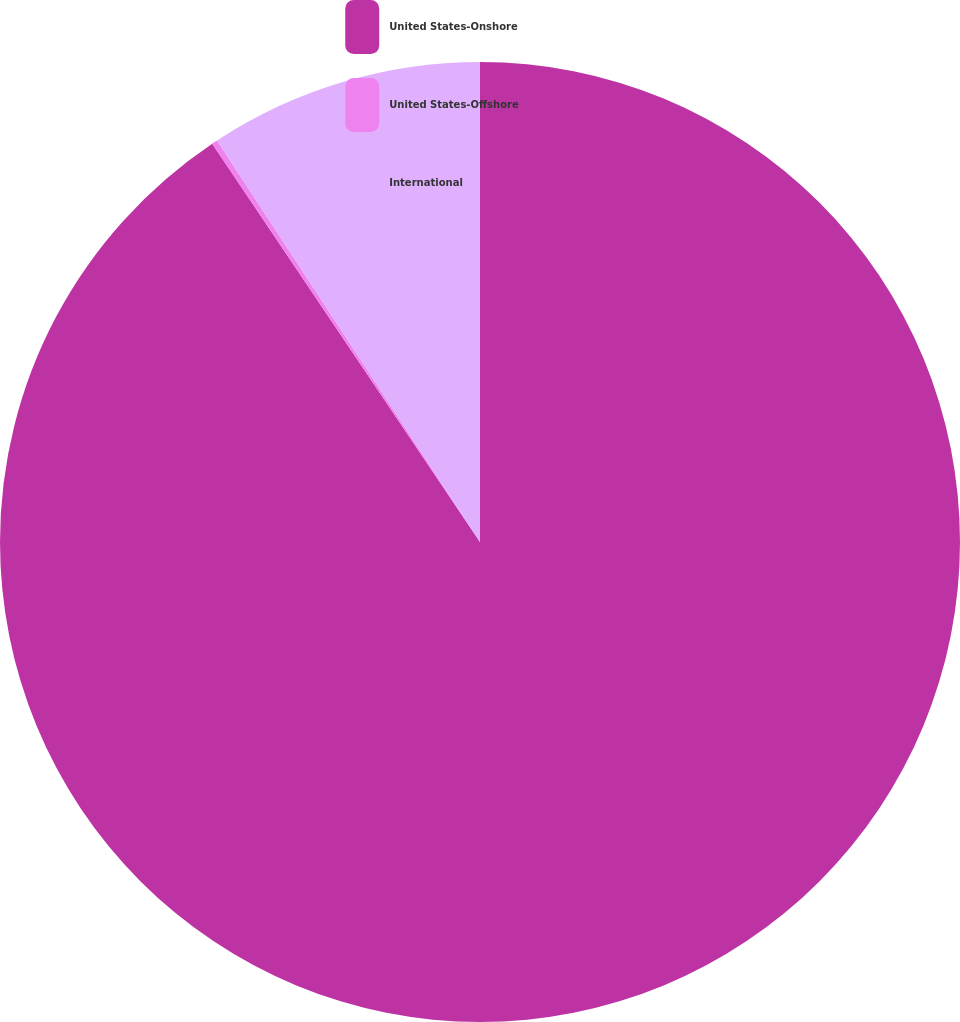<chart> <loc_0><loc_0><loc_500><loc_500><pie_chart><fcel>United States-Onshore<fcel>United States-Offshore<fcel>International<nl><fcel>90.58%<fcel>0.19%<fcel>9.23%<nl></chart> 